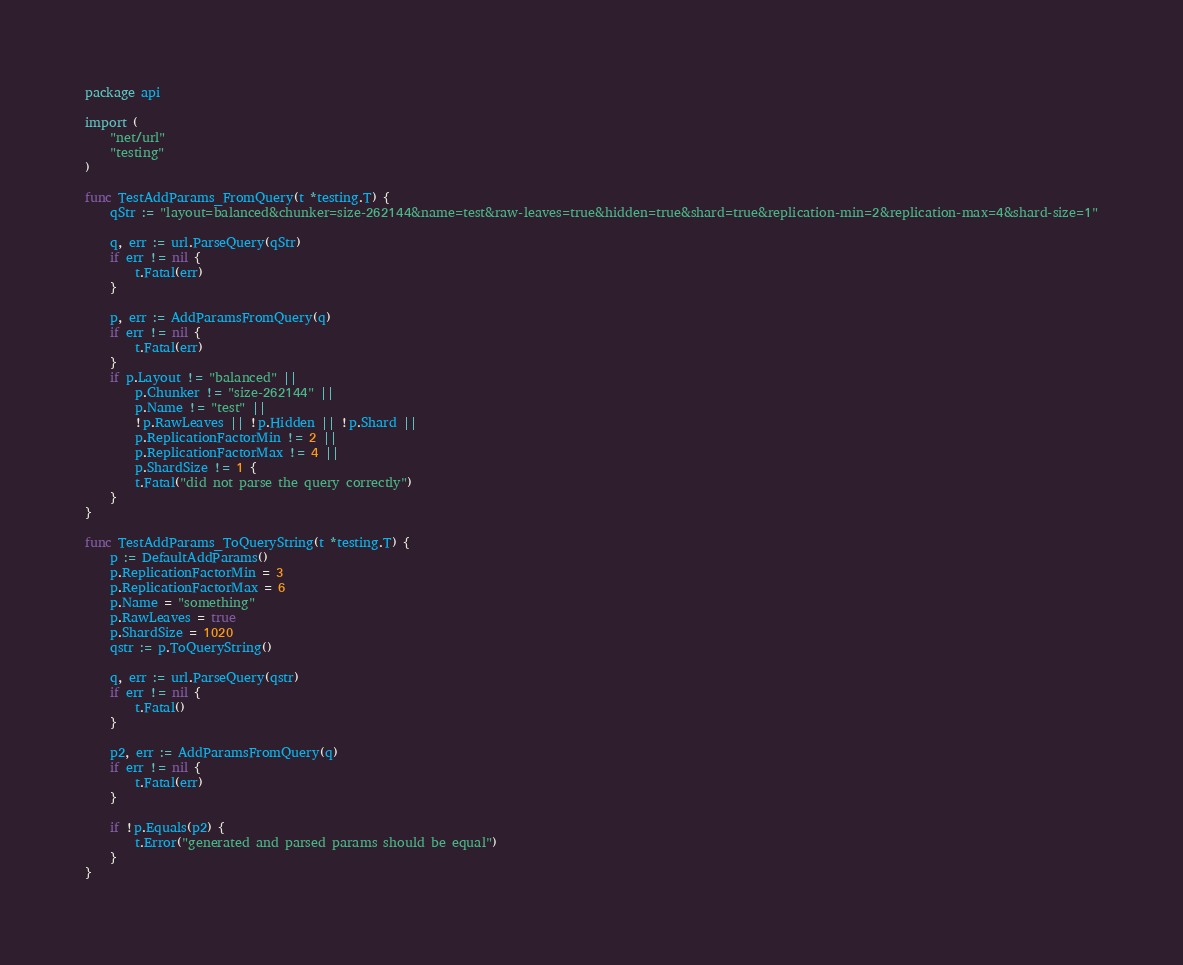Convert code to text. <code><loc_0><loc_0><loc_500><loc_500><_Go_>package api

import (
	"net/url"
	"testing"
)

func TestAddParams_FromQuery(t *testing.T) {
	qStr := "layout=balanced&chunker=size-262144&name=test&raw-leaves=true&hidden=true&shard=true&replication-min=2&replication-max=4&shard-size=1"

	q, err := url.ParseQuery(qStr)
	if err != nil {
		t.Fatal(err)
	}

	p, err := AddParamsFromQuery(q)
	if err != nil {
		t.Fatal(err)
	}
	if p.Layout != "balanced" ||
		p.Chunker != "size-262144" ||
		p.Name != "test" ||
		!p.RawLeaves || !p.Hidden || !p.Shard ||
		p.ReplicationFactorMin != 2 ||
		p.ReplicationFactorMax != 4 ||
		p.ShardSize != 1 {
		t.Fatal("did not parse the query correctly")
	}
}

func TestAddParams_ToQueryString(t *testing.T) {
	p := DefaultAddParams()
	p.ReplicationFactorMin = 3
	p.ReplicationFactorMax = 6
	p.Name = "something"
	p.RawLeaves = true
	p.ShardSize = 1020
	qstr := p.ToQueryString()

	q, err := url.ParseQuery(qstr)
	if err != nil {
		t.Fatal()
	}

	p2, err := AddParamsFromQuery(q)
	if err != nil {
		t.Fatal(err)
	}

	if !p.Equals(p2) {
		t.Error("generated and parsed params should be equal")
	}
}
</code> 